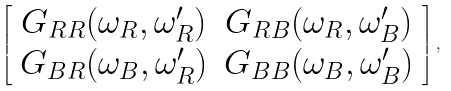Convert formula to latex. <formula><loc_0><loc_0><loc_500><loc_500>\left [ \begin{array} { c c } G _ { R R } ( \omega _ { R } , \omega ^ { \prime } _ { R } ) & G _ { R B } ( \omega _ { R } , \omega ^ { \prime } _ { B } ) \\ G _ { B R } ( \omega _ { B } , \omega ^ { \prime } _ { R } ) & G _ { B B } ( \omega _ { B } , \omega ^ { \prime } _ { B } ) \end{array} \right ] ,</formula> 